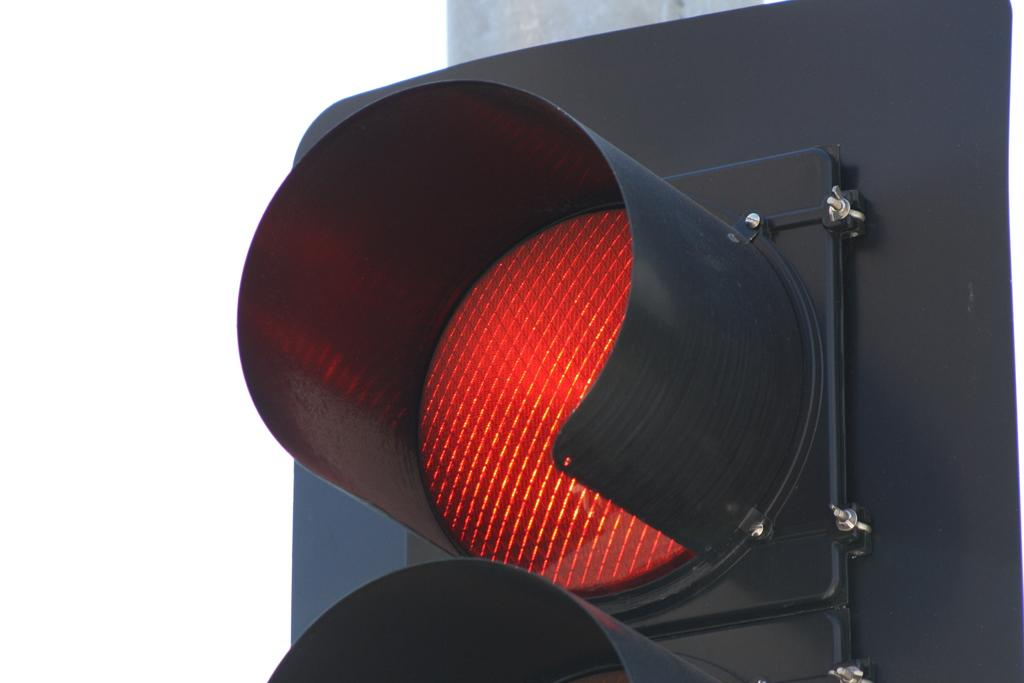What is the main object in the image? There is a signal light in the image. What color is the signal light? The signal light is red. What is the color of the background in the image? The background in the image is white. How many rings are visible on the signal light in the image? There are no rings present on the signal light in the image. What type of lace can be seen decorating the signal light in the image? There is no lace present on the signal light in the image. 